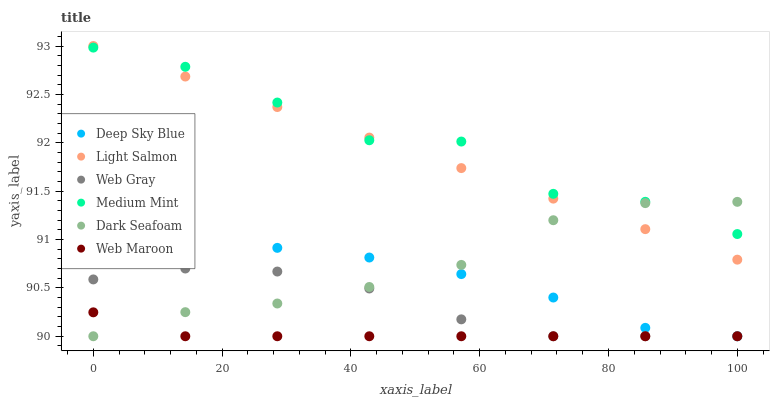Does Web Maroon have the minimum area under the curve?
Answer yes or no. Yes. Does Medium Mint have the maximum area under the curve?
Answer yes or no. Yes. Does Light Salmon have the minimum area under the curve?
Answer yes or no. No. Does Light Salmon have the maximum area under the curve?
Answer yes or no. No. Is Light Salmon the smoothest?
Answer yes or no. Yes. Is Medium Mint the roughest?
Answer yes or no. Yes. Is Web Gray the smoothest?
Answer yes or no. No. Is Web Gray the roughest?
Answer yes or no. No. Does Web Gray have the lowest value?
Answer yes or no. Yes. Does Light Salmon have the lowest value?
Answer yes or no. No. Does Light Salmon have the highest value?
Answer yes or no. Yes. Does Web Gray have the highest value?
Answer yes or no. No. Is Deep Sky Blue less than Medium Mint?
Answer yes or no. Yes. Is Medium Mint greater than Web Gray?
Answer yes or no. Yes. Does Web Gray intersect Dark Seafoam?
Answer yes or no. Yes. Is Web Gray less than Dark Seafoam?
Answer yes or no. No. Is Web Gray greater than Dark Seafoam?
Answer yes or no. No. Does Deep Sky Blue intersect Medium Mint?
Answer yes or no. No. 